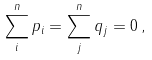Convert formula to latex. <formula><loc_0><loc_0><loc_500><loc_500>\sum _ { i } ^ { n } p _ { i } = \sum _ { j } ^ { n } q _ { j } = 0 \, ,</formula> 